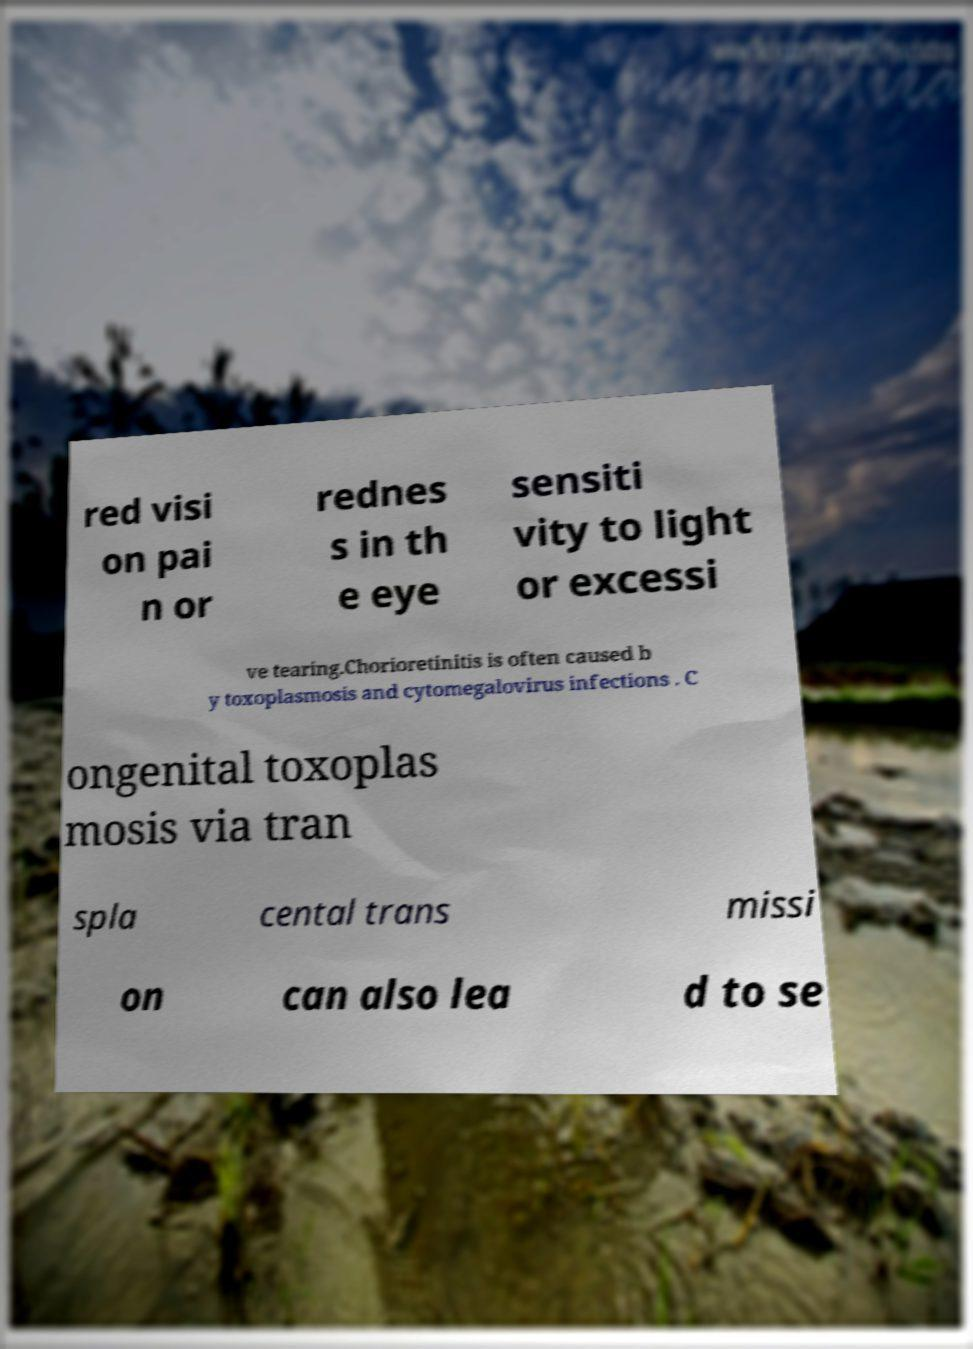Could you extract and type out the text from this image? red visi on pai n or rednes s in th e eye sensiti vity to light or excessi ve tearing.Chorioretinitis is often caused b y toxoplasmosis and cytomegalovirus infections . C ongenital toxoplas mosis via tran spla cental trans missi on can also lea d to se 